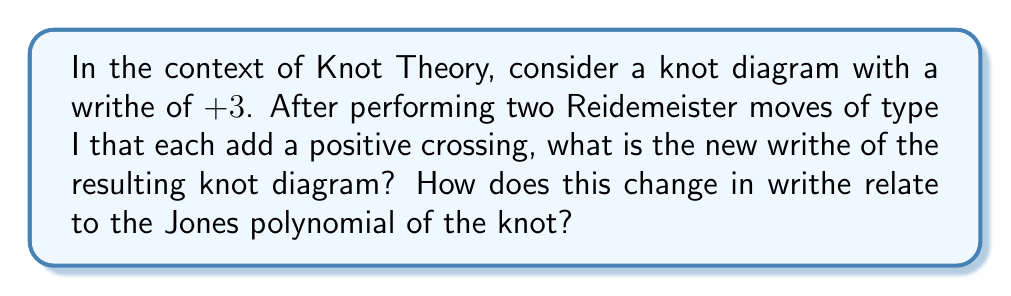Provide a solution to this math problem. To solve this problem, let's follow these steps:

1. Understand the initial state:
   The original knot diagram has a writhe of +3.

2. Analyze the Reidemeister moves:
   Two Reidemeister moves of type I are performed, each adding a positive crossing.
   Each type I move that adds a positive crossing increases the writhe by +1.

3. Calculate the new writhe:
   New writhe = Initial writhe + Change due to Reidemeister moves
   New writhe = +3 + (+1) + (+1) = +5

4. Relation to the Jones polynomial:
   The writhe is an important factor in calculating the Jones polynomial, but it's not an invariant under Reidemeister moves.
   The Jones polynomial, denoted as $V_K(t)$, is related to the writhe $w(K)$ through the following equation:

   $$f_K(A) = (-A^3)^{-w(K)} V_K(t)$$

   where $f_K(A)$ is the Kauffman bracket polynomial and $t = A^{-4}$.

5. Effect on the Jones polynomial:
   While the writhe has changed, the Jones polynomial remains invariant under Reidemeister moves.
   This means that despite the change in writhe from +3 to +5, the true Jones polynomial of the knot remains unchanged.

6. Interpretation:
   This example illustrates how local changes to a knot diagram (like Reidemeister moves) can affect some properties (like writhe) without changing fundamental invariants (like the Jones polynomial).
   This concept is crucial in distinguishing between properties of knot diagrams and true knot invariants.
Answer: New writhe: +5. Jones polynomial: Unchanged. 